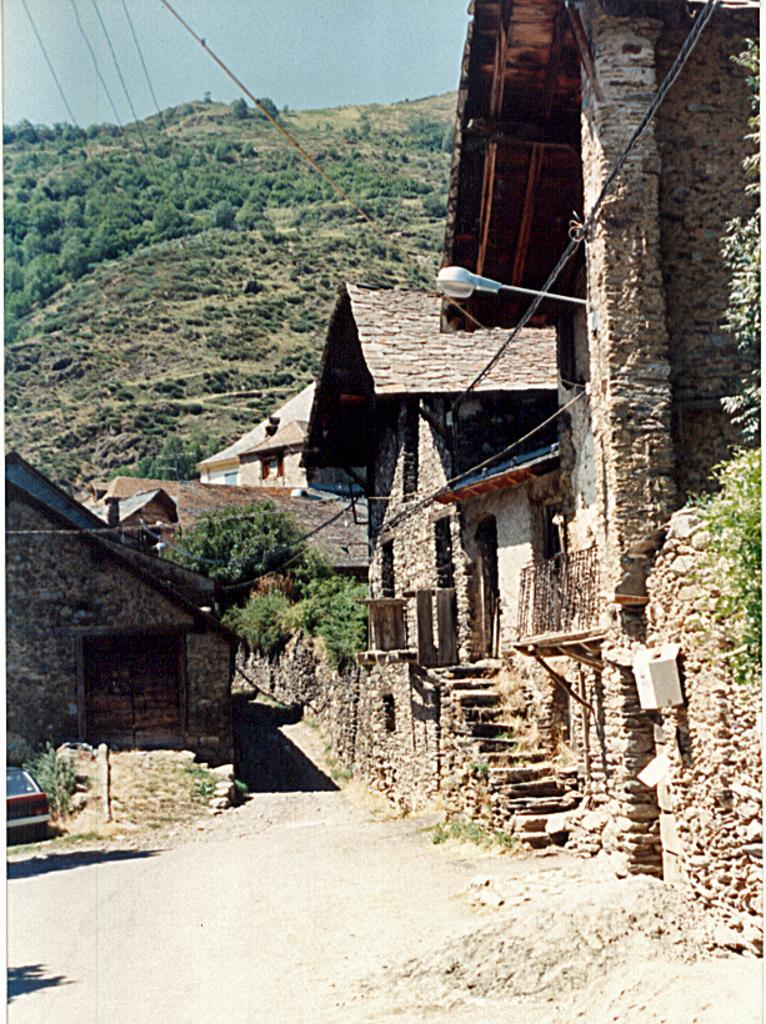What type of structures can be seen in the image? There are many buildings in the image. What type of natural elements are present in the image? There are trees, plants, and hills in the image. Are there any architectural features in the image? Yes, there are stairs in the image. How many fingers can be seen working on the earth in the image? There are no fingers or any indication of work or the earth present in the image. 